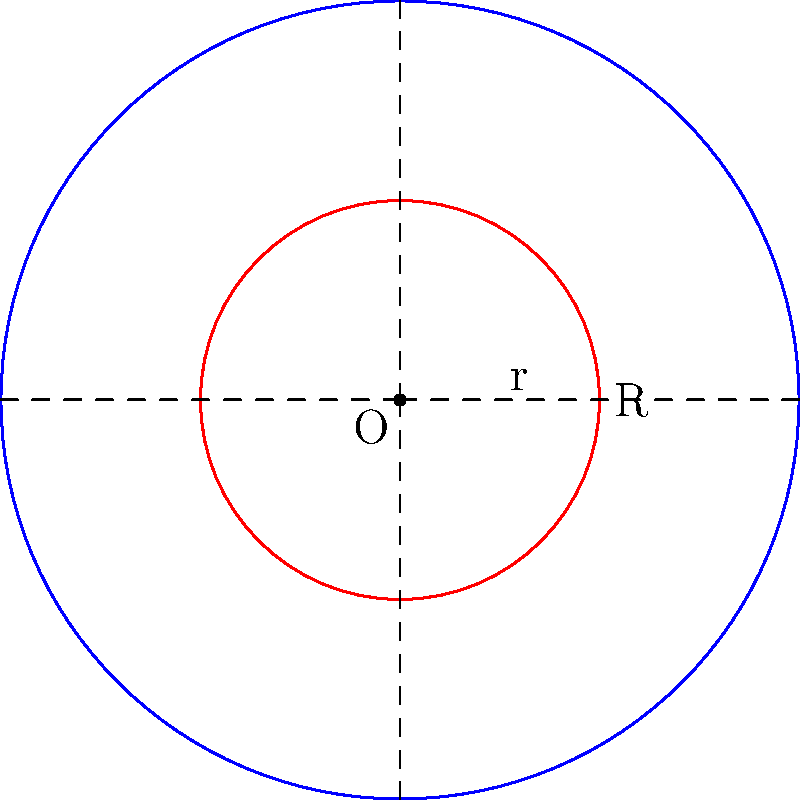In a kickboxing match, a fighter aims to land a kick within a circular target zone on their opponent's body. The entire target area has a radius of 3 units, while the most effective striking zone is a smaller concentric circle with a radius of 1.5 units. If the kick lands randomly within the larger circle, what is the probability that it will land within the smaller, more effective zone? Express your answer as a fraction. To solve this problem, we need to follow these steps:

1) The probability of the kick landing in the smaller circle is the ratio of the area of the smaller circle to the area of the larger circle.

2) The area of a circle is given by the formula $A = \pi r^2$, where $r$ is the radius.

3) For the larger circle:
   $A_1 = \pi R^2 = \pi (3)^2 = 9\pi$

4) For the smaller circle:
   $A_2 = \pi r^2 = \pi (1.5)^2 = 2.25\pi$

5) The probability is:

   $$P = \frac{A_2}{A_1} = \frac{2.25\pi}{9\pi} = \frac{2.25}{9} = \frac{1}{4}$$

6) We can simplify this fraction by dividing both numerator and denominator by 2.25:

   $$\frac{2.25}{9} = \frac{1}{4}$$

Therefore, the probability of the kick landing in the smaller, more effective zone is $\frac{1}{4}$ or 25%.
Answer: $\frac{1}{4}$ 